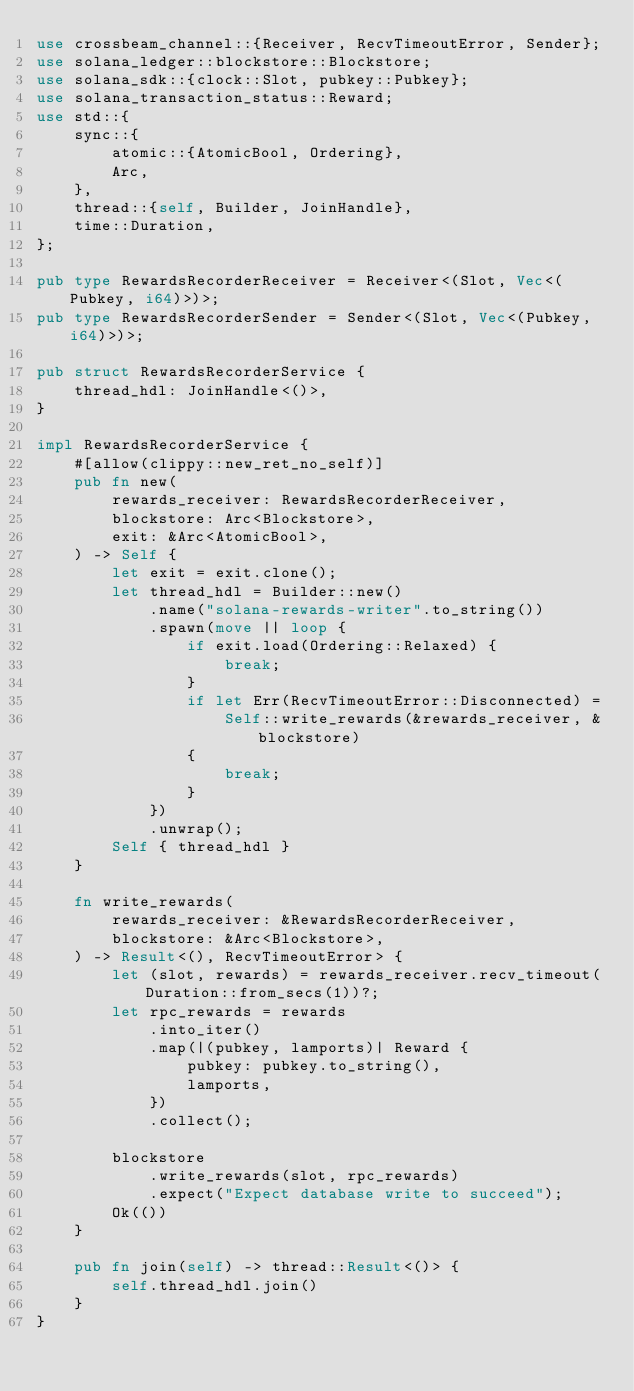Convert code to text. <code><loc_0><loc_0><loc_500><loc_500><_Rust_>use crossbeam_channel::{Receiver, RecvTimeoutError, Sender};
use solana_ledger::blockstore::Blockstore;
use solana_sdk::{clock::Slot, pubkey::Pubkey};
use solana_transaction_status::Reward;
use std::{
    sync::{
        atomic::{AtomicBool, Ordering},
        Arc,
    },
    thread::{self, Builder, JoinHandle},
    time::Duration,
};

pub type RewardsRecorderReceiver = Receiver<(Slot, Vec<(Pubkey, i64)>)>;
pub type RewardsRecorderSender = Sender<(Slot, Vec<(Pubkey, i64)>)>;

pub struct RewardsRecorderService {
    thread_hdl: JoinHandle<()>,
}

impl RewardsRecorderService {
    #[allow(clippy::new_ret_no_self)]
    pub fn new(
        rewards_receiver: RewardsRecorderReceiver,
        blockstore: Arc<Blockstore>,
        exit: &Arc<AtomicBool>,
    ) -> Self {
        let exit = exit.clone();
        let thread_hdl = Builder::new()
            .name("solana-rewards-writer".to_string())
            .spawn(move || loop {
                if exit.load(Ordering::Relaxed) {
                    break;
                }
                if let Err(RecvTimeoutError::Disconnected) =
                    Self::write_rewards(&rewards_receiver, &blockstore)
                {
                    break;
                }
            })
            .unwrap();
        Self { thread_hdl }
    }

    fn write_rewards(
        rewards_receiver: &RewardsRecorderReceiver,
        blockstore: &Arc<Blockstore>,
    ) -> Result<(), RecvTimeoutError> {
        let (slot, rewards) = rewards_receiver.recv_timeout(Duration::from_secs(1))?;
        let rpc_rewards = rewards
            .into_iter()
            .map(|(pubkey, lamports)| Reward {
                pubkey: pubkey.to_string(),
                lamports,
            })
            .collect();

        blockstore
            .write_rewards(slot, rpc_rewards)
            .expect("Expect database write to succeed");
        Ok(())
    }

    pub fn join(self) -> thread::Result<()> {
        self.thread_hdl.join()
    }
}
</code> 